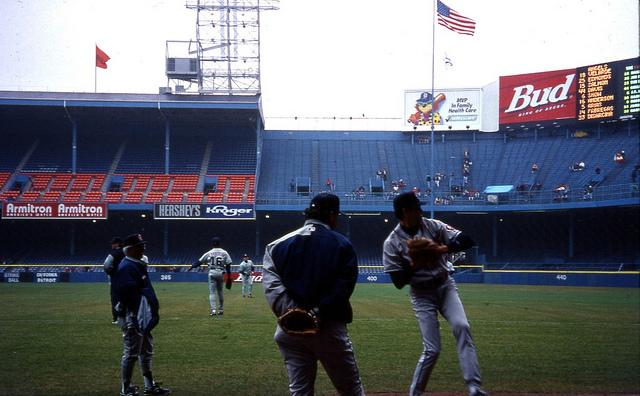Which advertiser is a watch company?

Choices:
A) armitron
B) bud
C) hershey's
D) kroger armitron 